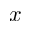<formula> <loc_0><loc_0><loc_500><loc_500>x</formula> 